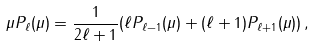Convert formula to latex. <formula><loc_0><loc_0><loc_500><loc_500>\mu P _ { \ell } ( \mu ) = \frac { 1 } { 2 \ell + 1 } ( \ell P _ { \ell - 1 } ( \mu ) + ( \ell + 1 ) P _ { \ell + 1 } ( \mu ) ) \, ,</formula> 